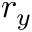Convert formula to latex. <formula><loc_0><loc_0><loc_500><loc_500>r _ { y }</formula> 